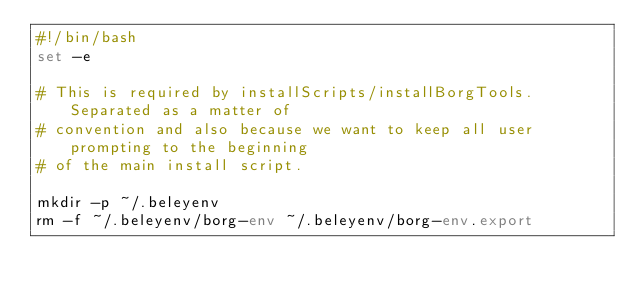Convert code to text. <code><loc_0><loc_0><loc_500><loc_500><_Bash_>#!/bin/bash
set -e 

# This is required by installScripts/installBorgTools.  Separated as a matter of
# convention and also because we want to keep all user prompting to the beginning
# of the main install script.

mkdir -p ~/.beleyenv
rm -f ~/.beleyenv/borg-env ~/.beleyenv/borg-env.export</code> 